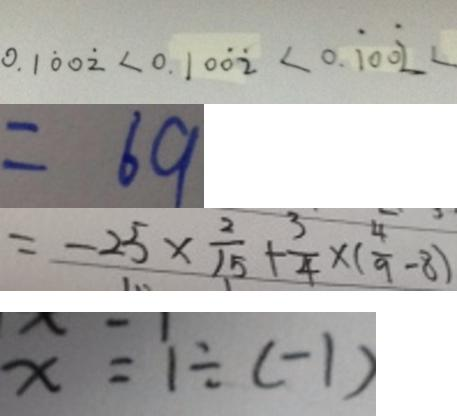<formula> <loc_0><loc_0><loc_500><loc_500>0 . 1 \dot { 0 } 0 \dot { 2 } < 0 . 1 0 \dot { 0 } \dot { 2 } < 0 . \dot { 1 } 0 0 \dot { 2 } < 
 = 6 9 
 = - 2 5 \times \frac { 2 } { 1 5 } + \frac { 3 } { 4 } \times ( \frac { 4 } { 9 } - 8 ) 
 x = 1 \div ( - 1 )</formula> 